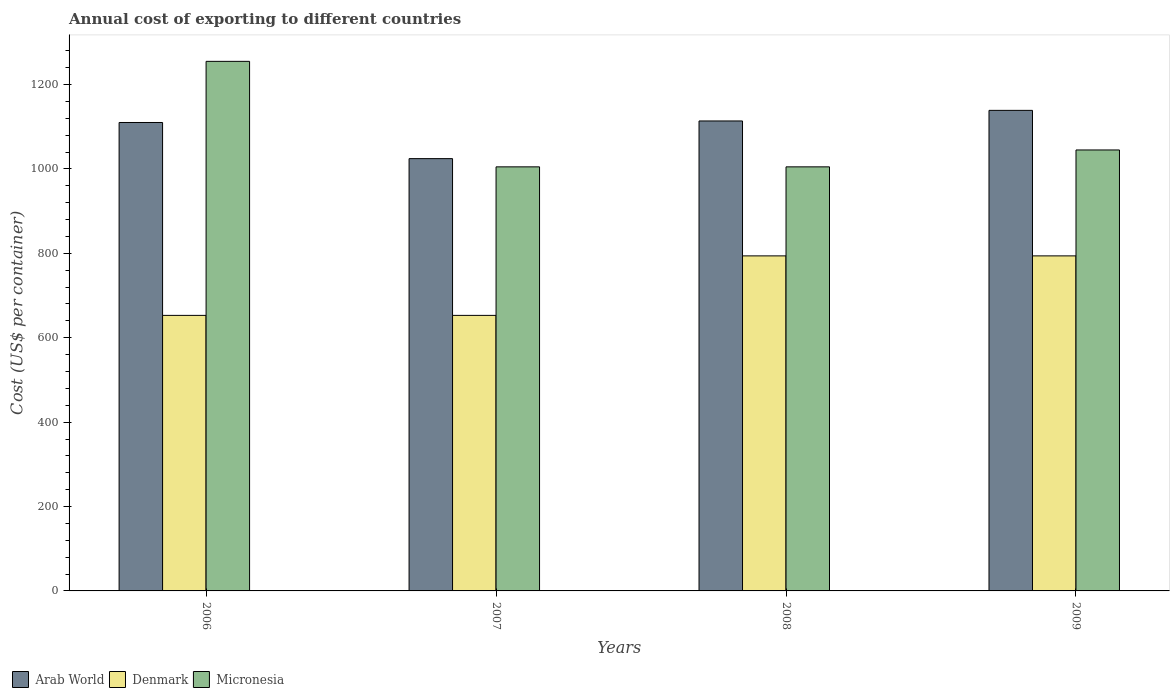How many bars are there on the 1st tick from the left?
Provide a short and direct response. 3. In how many cases, is the number of bars for a given year not equal to the number of legend labels?
Give a very brief answer. 0. What is the total annual cost of exporting in Micronesia in 2009?
Your response must be concise. 1045. Across all years, what is the maximum total annual cost of exporting in Arab World?
Your answer should be compact. 1138.85. Across all years, what is the minimum total annual cost of exporting in Micronesia?
Give a very brief answer. 1005. In which year was the total annual cost of exporting in Arab World minimum?
Provide a succinct answer. 2007. What is the total total annual cost of exporting in Micronesia in the graph?
Give a very brief answer. 4310. What is the difference between the total annual cost of exporting in Denmark in 2006 and that in 2009?
Your response must be concise. -141. What is the difference between the total annual cost of exporting in Arab World in 2008 and the total annual cost of exporting in Denmark in 2009?
Give a very brief answer. 319.75. What is the average total annual cost of exporting in Micronesia per year?
Your response must be concise. 1077.5. In the year 2006, what is the difference between the total annual cost of exporting in Micronesia and total annual cost of exporting in Denmark?
Offer a terse response. 602. What is the ratio of the total annual cost of exporting in Arab World in 2006 to that in 2008?
Offer a very short reply. 1. Is the difference between the total annual cost of exporting in Micronesia in 2007 and 2008 greater than the difference between the total annual cost of exporting in Denmark in 2007 and 2008?
Offer a very short reply. Yes. What is the difference between the highest and the second highest total annual cost of exporting in Micronesia?
Provide a succinct answer. 210. What is the difference between the highest and the lowest total annual cost of exporting in Arab World?
Provide a succinct answer. 114.4. In how many years, is the total annual cost of exporting in Micronesia greater than the average total annual cost of exporting in Micronesia taken over all years?
Your answer should be compact. 1. Is the sum of the total annual cost of exporting in Arab World in 2006 and 2008 greater than the maximum total annual cost of exporting in Denmark across all years?
Your response must be concise. Yes. What does the 1st bar from the left in 2006 represents?
Ensure brevity in your answer.  Arab World. What does the 3rd bar from the right in 2009 represents?
Give a very brief answer. Arab World. Is it the case that in every year, the sum of the total annual cost of exporting in Micronesia and total annual cost of exporting in Arab World is greater than the total annual cost of exporting in Denmark?
Your answer should be very brief. Yes. How many bars are there?
Provide a succinct answer. 12. Where does the legend appear in the graph?
Provide a short and direct response. Bottom left. What is the title of the graph?
Provide a short and direct response. Annual cost of exporting to different countries. Does "Sweden" appear as one of the legend labels in the graph?
Offer a very short reply. No. What is the label or title of the Y-axis?
Your response must be concise. Cost (US$ per container). What is the Cost (US$ per container) in Arab World in 2006?
Offer a very short reply. 1110.11. What is the Cost (US$ per container) in Denmark in 2006?
Your response must be concise. 653. What is the Cost (US$ per container) in Micronesia in 2006?
Offer a very short reply. 1255. What is the Cost (US$ per container) of Arab World in 2007?
Ensure brevity in your answer.  1024.45. What is the Cost (US$ per container) of Denmark in 2007?
Your response must be concise. 653. What is the Cost (US$ per container) in Micronesia in 2007?
Keep it short and to the point. 1005. What is the Cost (US$ per container) in Arab World in 2008?
Provide a short and direct response. 1113.75. What is the Cost (US$ per container) in Denmark in 2008?
Your answer should be compact. 794. What is the Cost (US$ per container) in Micronesia in 2008?
Provide a short and direct response. 1005. What is the Cost (US$ per container) of Arab World in 2009?
Ensure brevity in your answer.  1138.85. What is the Cost (US$ per container) of Denmark in 2009?
Provide a short and direct response. 794. What is the Cost (US$ per container) of Micronesia in 2009?
Your answer should be very brief. 1045. Across all years, what is the maximum Cost (US$ per container) in Arab World?
Keep it short and to the point. 1138.85. Across all years, what is the maximum Cost (US$ per container) in Denmark?
Make the answer very short. 794. Across all years, what is the maximum Cost (US$ per container) in Micronesia?
Give a very brief answer. 1255. Across all years, what is the minimum Cost (US$ per container) of Arab World?
Your answer should be very brief. 1024.45. Across all years, what is the minimum Cost (US$ per container) in Denmark?
Provide a succinct answer. 653. Across all years, what is the minimum Cost (US$ per container) of Micronesia?
Provide a succinct answer. 1005. What is the total Cost (US$ per container) in Arab World in the graph?
Ensure brevity in your answer.  4387.16. What is the total Cost (US$ per container) in Denmark in the graph?
Provide a succinct answer. 2894. What is the total Cost (US$ per container) in Micronesia in the graph?
Offer a very short reply. 4310. What is the difference between the Cost (US$ per container) in Arab World in 2006 and that in 2007?
Give a very brief answer. 85.66. What is the difference between the Cost (US$ per container) in Micronesia in 2006 and that in 2007?
Your answer should be very brief. 250. What is the difference between the Cost (US$ per container) of Arab World in 2006 and that in 2008?
Your answer should be very brief. -3.64. What is the difference between the Cost (US$ per container) of Denmark in 2006 and that in 2008?
Offer a terse response. -141. What is the difference between the Cost (US$ per container) of Micronesia in 2006 and that in 2008?
Keep it short and to the point. 250. What is the difference between the Cost (US$ per container) of Arab World in 2006 and that in 2009?
Ensure brevity in your answer.  -28.74. What is the difference between the Cost (US$ per container) in Denmark in 2006 and that in 2009?
Give a very brief answer. -141. What is the difference between the Cost (US$ per container) of Micronesia in 2006 and that in 2009?
Your answer should be compact. 210. What is the difference between the Cost (US$ per container) of Arab World in 2007 and that in 2008?
Your response must be concise. -89.3. What is the difference between the Cost (US$ per container) of Denmark in 2007 and that in 2008?
Offer a terse response. -141. What is the difference between the Cost (US$ per container) of Arab World in 2007 and that in 2009?
Offer a very short reply. -114.4. What is the difference between the Cost (US$ per container) of Denmark in 2007 and that in 2009?
Offer a very short reply. -141. What is the difference between the Cost (US$ per container) of Micronesia in 2007 and that in 2009?
Give a very brief answer. -40. What is the difference between the Cost (US$ per container) of Arab World in 2008 and that in 2009?
Offer a terse response. -25.1. What is the difference between the Cost (US$ per container) of Micronesia in 2008 and that in 2009?
Keep it short and to the point. -40. What is the difference between the Cost (US$ per container) in Arab World in 2006 and the Cost (US$ per container) in Denmark in 2007?
Make the answer very short. 457.11. What is the difference between the Cost (US$ per container) of Arab World in 2006 and the Cost (US$ per container) of Micronesia in 2007?
Give a very brief answer. 105.11. What is the difference between the Cost (US$ per container) in Denmark in 2006 and the Cost (US$ per container) in Micronesia in 2007?
Provide a succinct answer. -352. What is the difference between the Cost (US$ per container) in Arab World in 2006 and the Cost (US$ per container) in Denmark in 2008?
Keep it short and to the point. 316.11. What is the difference between the Cost (US$ per container) of Arab World in 2006 and the Cost (US$ per container) of Micronesia in 2008?
Give a very brief answer. 105.11. What is the difference between the Cost (US$ per container) of Denmark in 2006 and the Cost (US$ per container) of Micronesia in 2008?
Provide a short and direct response. -352. What is the difference between the Cost (US$ per container) of Arab World in 2006 and the Cost (US$ per container) of Denmark in 2009?
Your answer should be very brief. 316.11. What is the difference between the Cost (US$ per container) of Arab World in 2006 and the Cost (US$ per container) of Micronesia in 2009?
Provide a succinct answer. 65.11. What is the difference between the Cost (US$ per container) in Denmark in 2006 and the Cost (US$ per container) in Micronesia in 2009?
Your response must be concise. -392. What is the difference between the Cost (US$ per container) of Arab World in 2007 and the Cost (US$ per container) of Denmark in 2008?
Make the answer very short. 230.45. What is the difference between the Cost (US$ per container) in Arab World in 2007 and the Cost (US$ per container) in Micronesia in 2008?
Give a very brief answer. 19.45. What is the difference between the Cost (US$ per container) in Denmark in 2007 and the Cost (US$ per container) in Micronesia in 2008?
Keep it short and to the point. -352. What is the difference between the Cost (US$ per container) in Arab World in 2007 and the Cost (US$ per container) in Denmark in 2009?
Ensure brevity in your answer.  230.45. What is the difference between the Cost (US$ per container) in Arab World in 2007 and the Cost (US$ per container) in Micronesia in 2009?
Provide a succinct answer. -20.55. What is the difference between the Cost (US$ per container) in Denmark in 2007 and the Cost (US$ per container) in Micronesia in 2009?
Make the answer very short. -392. What is the difference between the Cost (US$ per container) in Arab World in 2008 and the Cost (US$ per container) in Denmark in 2009?
Offer a very short reply. 319.75. What is the difference between the Cost (US$ per container) of Arab World in 2008 and the Cost (US$ per container) of Micronesia in 2009?
Make the answer very short. 68.75. What is the difference between the Cost (US$ per container) in Denmark in 2008 and the Cost (US$ per container) in Micronesia in 2009?
Provide a succinct answer. -251. What is the average Cost (US$ per container) of Arab World per year?
Your response must be concise. 1096.79. What is the average Cost (US$ per container) in Denmark per year?
Offer a very short reply. 723.5. What is the average Cost (US$ per container) in Micronesia per year?
Your answer should be very brief. 1077.5. In the year 2006, what is the difference between the Cost (US$ per container) of Arab World and Cost (US$ per container) of Denmark?
Provide a succinct answer. 457.11. In the year 2006, what is the difference between the Cost (US$ per container) in Arab World and Cost (US$ per container) in Micronesia?
Your answer should be very brief. -144.89. In the year 2006, what is the difference between the Cost (US$ per container) in Denmark and Cost (US$ per container) in Micronesia?
Keep it short and to the point. -602. In the year 2007, what is the difference between the Cost (US$ per container) of Arab World and Cost (US$ per container) of Denmark?
Give a very brief answer. 371.45. In the year 2007, what is the difference between the Cost (US$ per container) of Arab World and Cost (US$ per container) of Micronesia?
Make the answer very short. 19.45. In the year 2007, what is the difference between the Cost (US$ per container) in Denmark and Cost (US$ per container) in Micronesia?
Offer a terse response. -352. In the year 2008, what is the difference between the Cost (US$ per container) of Arab World and Cost (US$ per container) of Denmark?
Your answer should be very brief. 319.75. In the year 2008, what is the difference between the Cost (US$ per container) in Arab World and Cost (US$ per container) in Micronesia?
Provide a short and direct response. 108.75. In the year 2008, what is the difference between the Cost (US$ per container) of Denmark and Cost (US$ per container) of Micronesia?
Ensure brevity in your answer.  -211. In the year 2009, what is the difference between the Cost (US$ per container) of Arab World and Cost (US$ per container) of Denmark?
Give a very brief answer. 344.85. In the year 2009, what is the difference between the Cost (US$ per container) in Arab World and Cost (US$ per container) in Micronesia?
Make the answer very short. 93.85. In the year 2009, what is the difference between the Cost (US$ per container) of Denmark and Cost (US$ per container) of Micronesia?
Offer a terse response. -251. What is the ratio of the Cost (US$ per container) of Arab World in 2006 to that in 2007?
Keep it short and to the point. 1.08. What is the ratio of the Cost (US$ per container) in Micronesia in 2006 to that in 2007?
Give a very brief answer. 1.25. What is the ratio of the Cost (US$ per container) of Arab World in 2006 to that in 2008?
Provide a succinct answer. 1. What is the ratio of the Cost (US$ per container) of Denmark in 2006 to that in 2008?
Your answer should be compact. 0.82. What is the ratio of the Cost (US$ per container) of Micronesia in 2006 to that in 2008?
Ensure brevity in your answer.  1.25. What is the ratio of the Cost (US$ per container) of Arab World in 2006 to that in 2009?
Ensure brevity in your answer.  0.97. What is the ratio of the Cost (US$ per container) in Denmark in 2006 to that in 2009?
Your response must be concise. 0.82. What is the ratio of the Cost (US$ per container) of Micronesia in 2006 to that in 2009?
Offer a terse response. 1.2. What is the ratio of the Cost (US$ per container) in Arab World in 2007 to that in 2008?
Make the answer very short. 0.92. What is the ratio of the Cost (US$ per container) in Denmark in 2007 to that in 2008?
Provide a short and direct response. 0.82. What is the ratio of the Cost (US$ per container) in Micronesia in 2007 to that in 2008?
Your answer should be very brief. 1. What is the ratio of the Cost (US$ per container) of Arab World in 2007 to that in 2009?
Keep it short and to the point. 0.9. What is the ratio of the Cost (US$ per container) in Denmark in 2007 to that in 2009?
Provide a short and direct response. 0.82. What is the ratio of the Cost (US$ per container) in Micronesia in 2007 to that in 2009?
Offer a very short reply. 0.96. What is the ratio of the Cost (US$ per container) of Denmark in 2008 to that in 2009?
Provide a succinct answer. 1. What is the ratio of the Cost (US$ per container) of Micronesia in 2008 to that in 2009?
Offer a very short reply. 0.96. What is the difference between the highest and the second highest Cost (US$ per container) in Arab World?
Provide a succinct answer. 25.1. What is the difference between the highest and the second highest Cost (US$ per container) in Micronesia?
Your answer should be compact. 210. What is the difference between the highest and the lowest Cost (US$ per container) of Arab World?
Offer a terse response. 114.4. What is the difference between the highest and the lowest Cost (US$ per container) of Denmark?
Keep it short and to the point. 141. What is the difference between the highest and the lowest Cost (US$ per container) of Micronesia?
Your answer should be very brief. 250. 